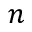Convert formula to latex. <formula><loc_0><loc_0><loc_500><loc_500>n</formula> 